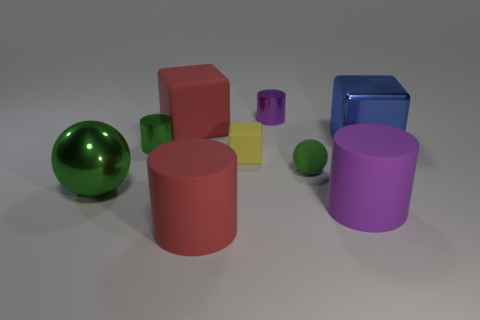The large sphere is what color?
Your answer should be compact. Green. What number of other objects are the same color as the small sphere?
Make the answer very short. 2. There is a green matte ball; are there any big cylinders on the right side of it?
Your answer should be very brief. Yes. There is a tiny cylinder in front of the small object that is behind the large object right of the big purple cylinder; what is its color?
Your response must be concise. Green. What number of cylinders are left of the tiny yellow rubber block and behind the large red matte cylinder?
Keep it short and to the point. 1. What number of spheres are big purple objects or large blue metallic things?
Provide a short and direct response. 0. Is there a purple metallic cylinder?
Offer a very short reply. Yes. What number of other objects are there of the same material as the big blue cube?
Ensure brevity in your answer.  3. What material is the purple object that is the same size as the yellow matte cube?
Make the answer very short. Metal. There is a red thing behind the green cylinder; is it the same shape as the blue object?
Provide a succinct answer. Yes. 